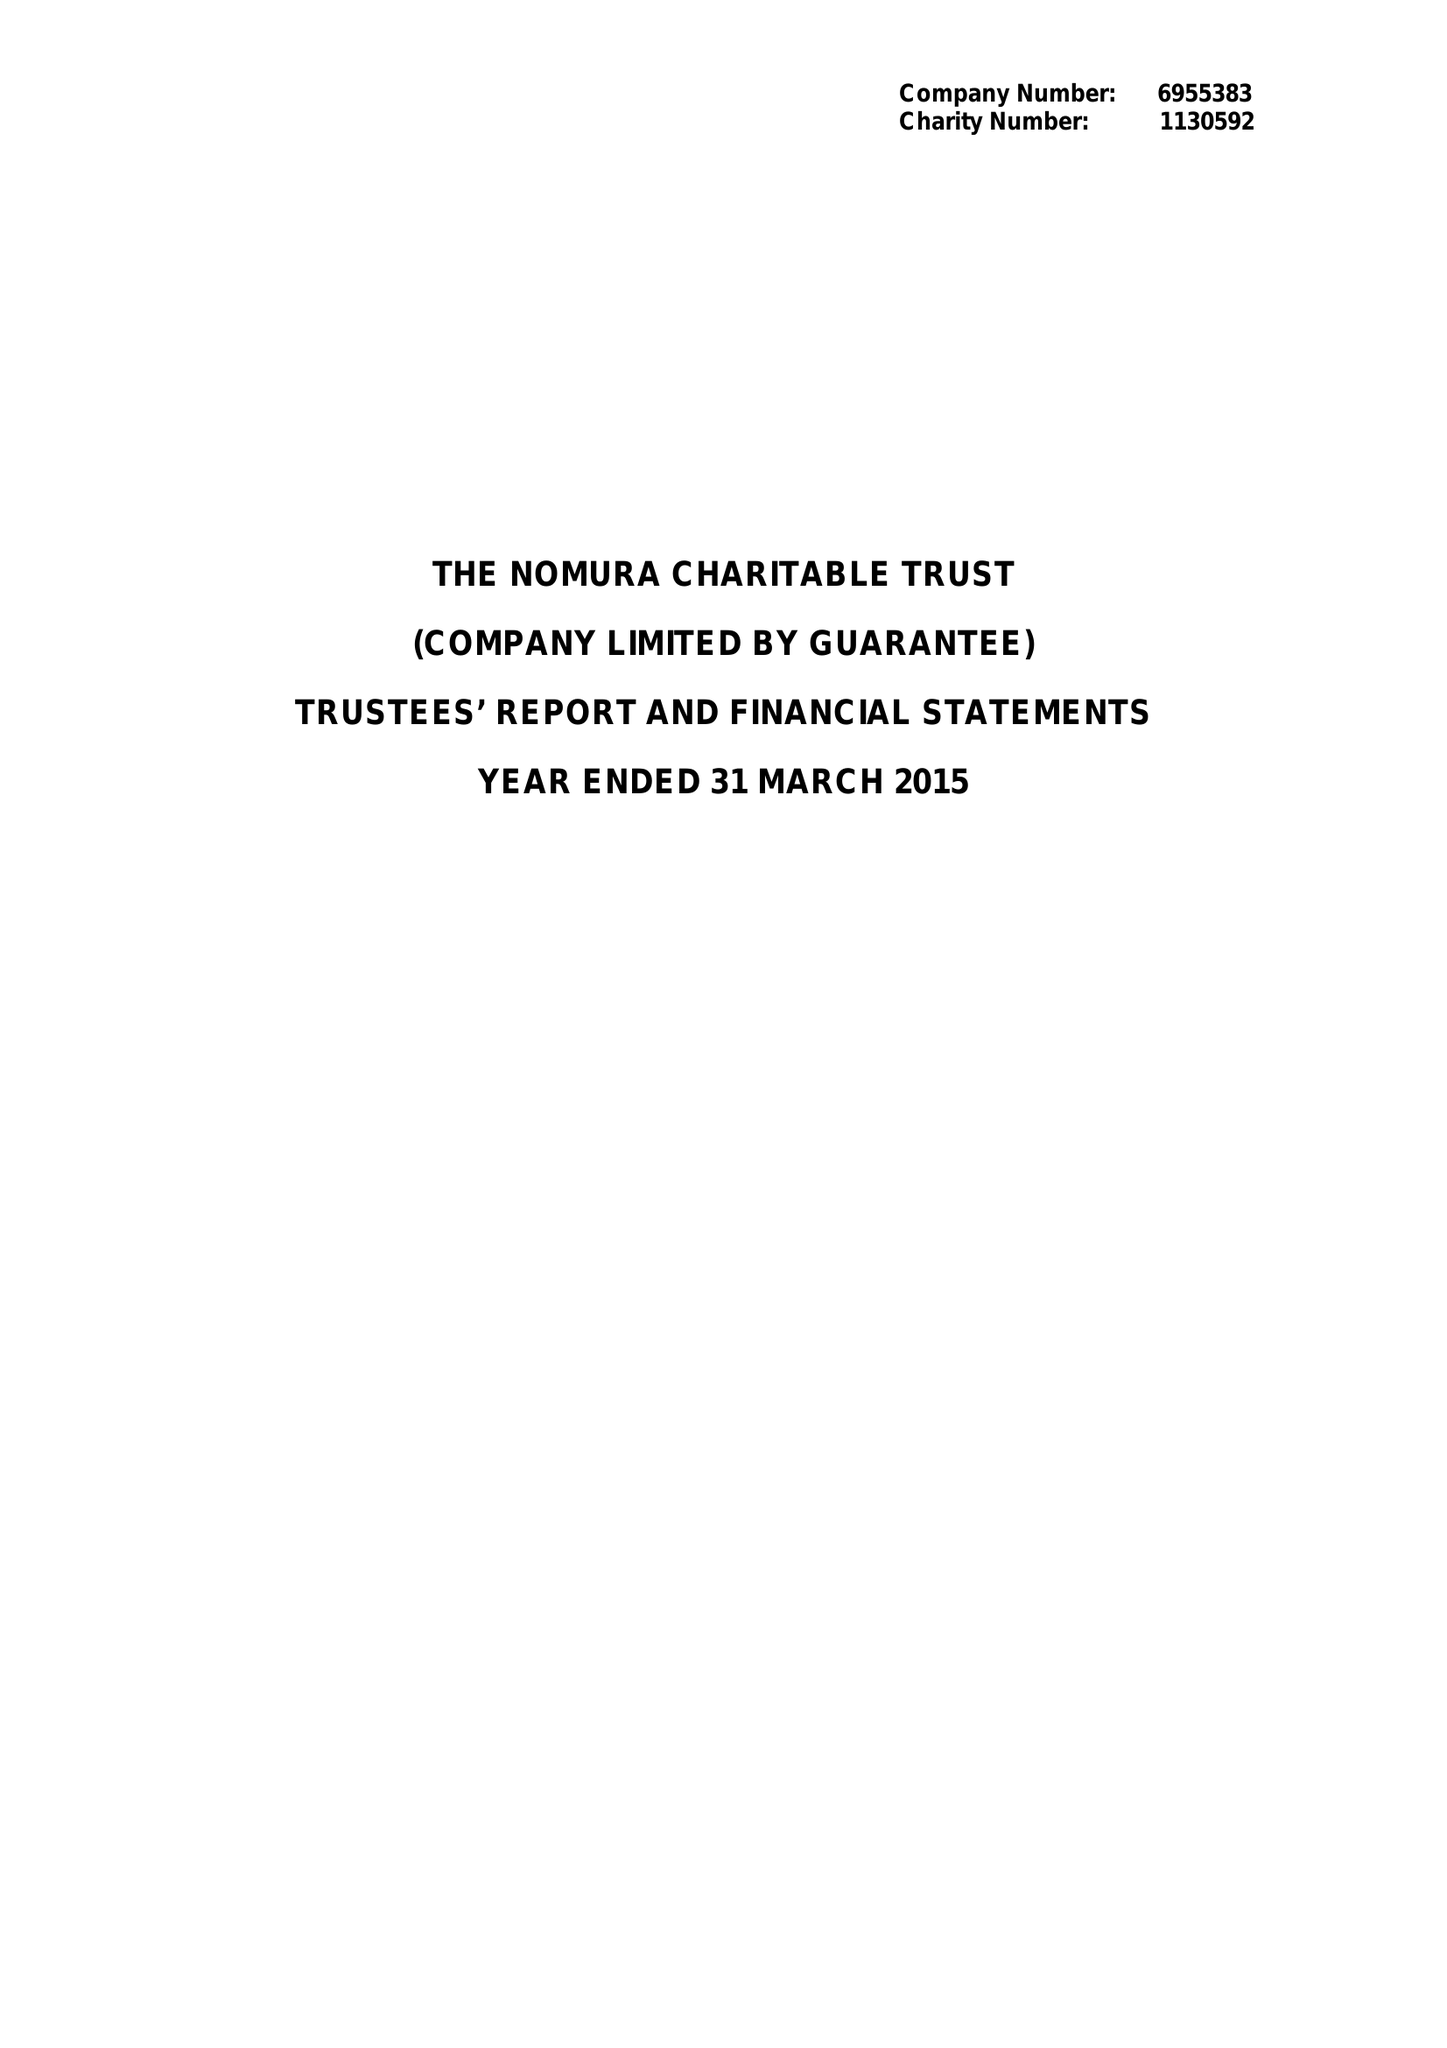What is the value for the spending_annually_in_british_pounds?
Answer the question using a single word or phrase. 390981.00 